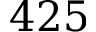<formula> <loc_0><loc_0><loc_500><loc_500>4 2 5</formula> 